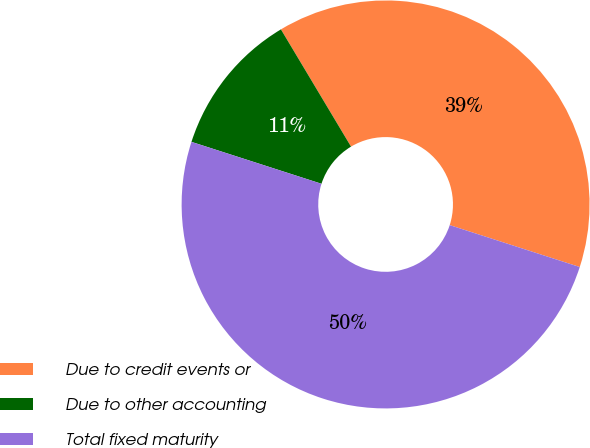<chart> <loc_0><loc_0><loc_500><loc_500><pie_chart><fcel>Due to credit events or<fcel>Due to other accounting<fcel>Total fixed maturity<nl><fcel>38.54%<fcel>11.46%<fcel>50.0%<nl></chart> 